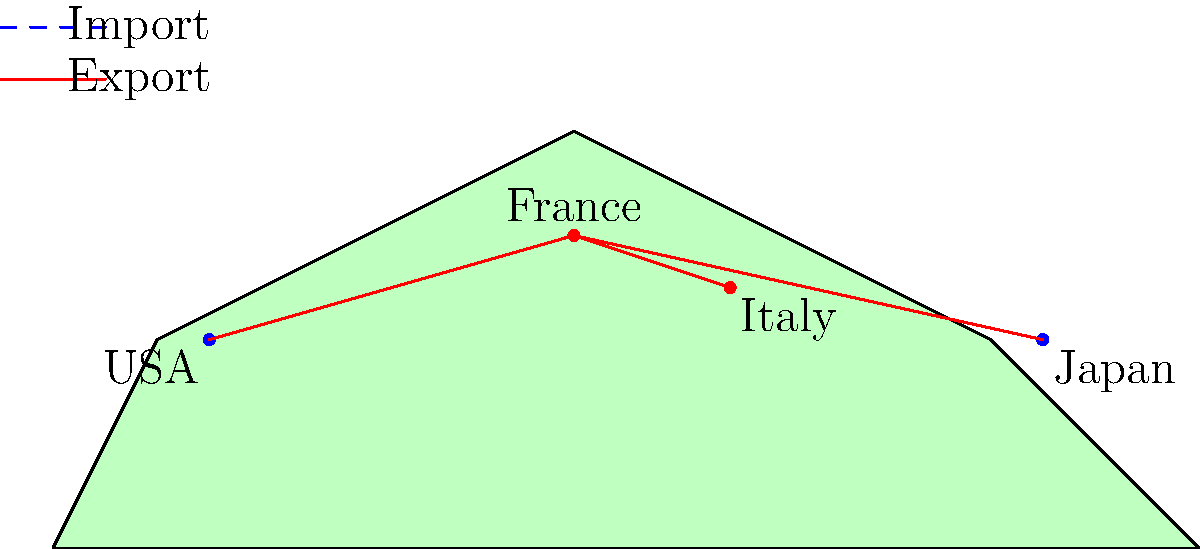Based on the world map showing import/export routes for gourmet foods, which country appears to be both a major importer and exporter of French gourmet products, and why might this be significant for a French gourmet food importer? 1. Examine the map: The map shows France as the central point, with import and export routes connecting to other countries.

2. Identify import routes: Blue dashed lines represent imports to France from the USA and Japan.

3. Identify export routes: Red solid lines represent exports from France to Italy, USA, and Japan.

4. Analyze the routes: The USA stands out as it has both an import (blue dashed) and export (red solid) line connecting to France.

5. Consider the significance: 
   a) The USA being both an importer and exporter suggests a strong trade relationship with France in gourmet foods.
   b) This indicates a mature market for French products in the USA.
   c) It also implies that the USA produces gourmet products of interest to French consumers.

6. Implications for a French gourmet food importer:
   a) Potential for two-way trade, allowing for a diverse product offering.
   b) Opportunity to establish strong business relationships with American suppliers and buyers.
   c) Possibility of introducing American gourmet products to the French market.
   d) Potential for economies of scale in shipping and logistics due to bi-directional trade.
Answer: USA; bi-directional trade offers diverse product opportunities and efficient logistics. 